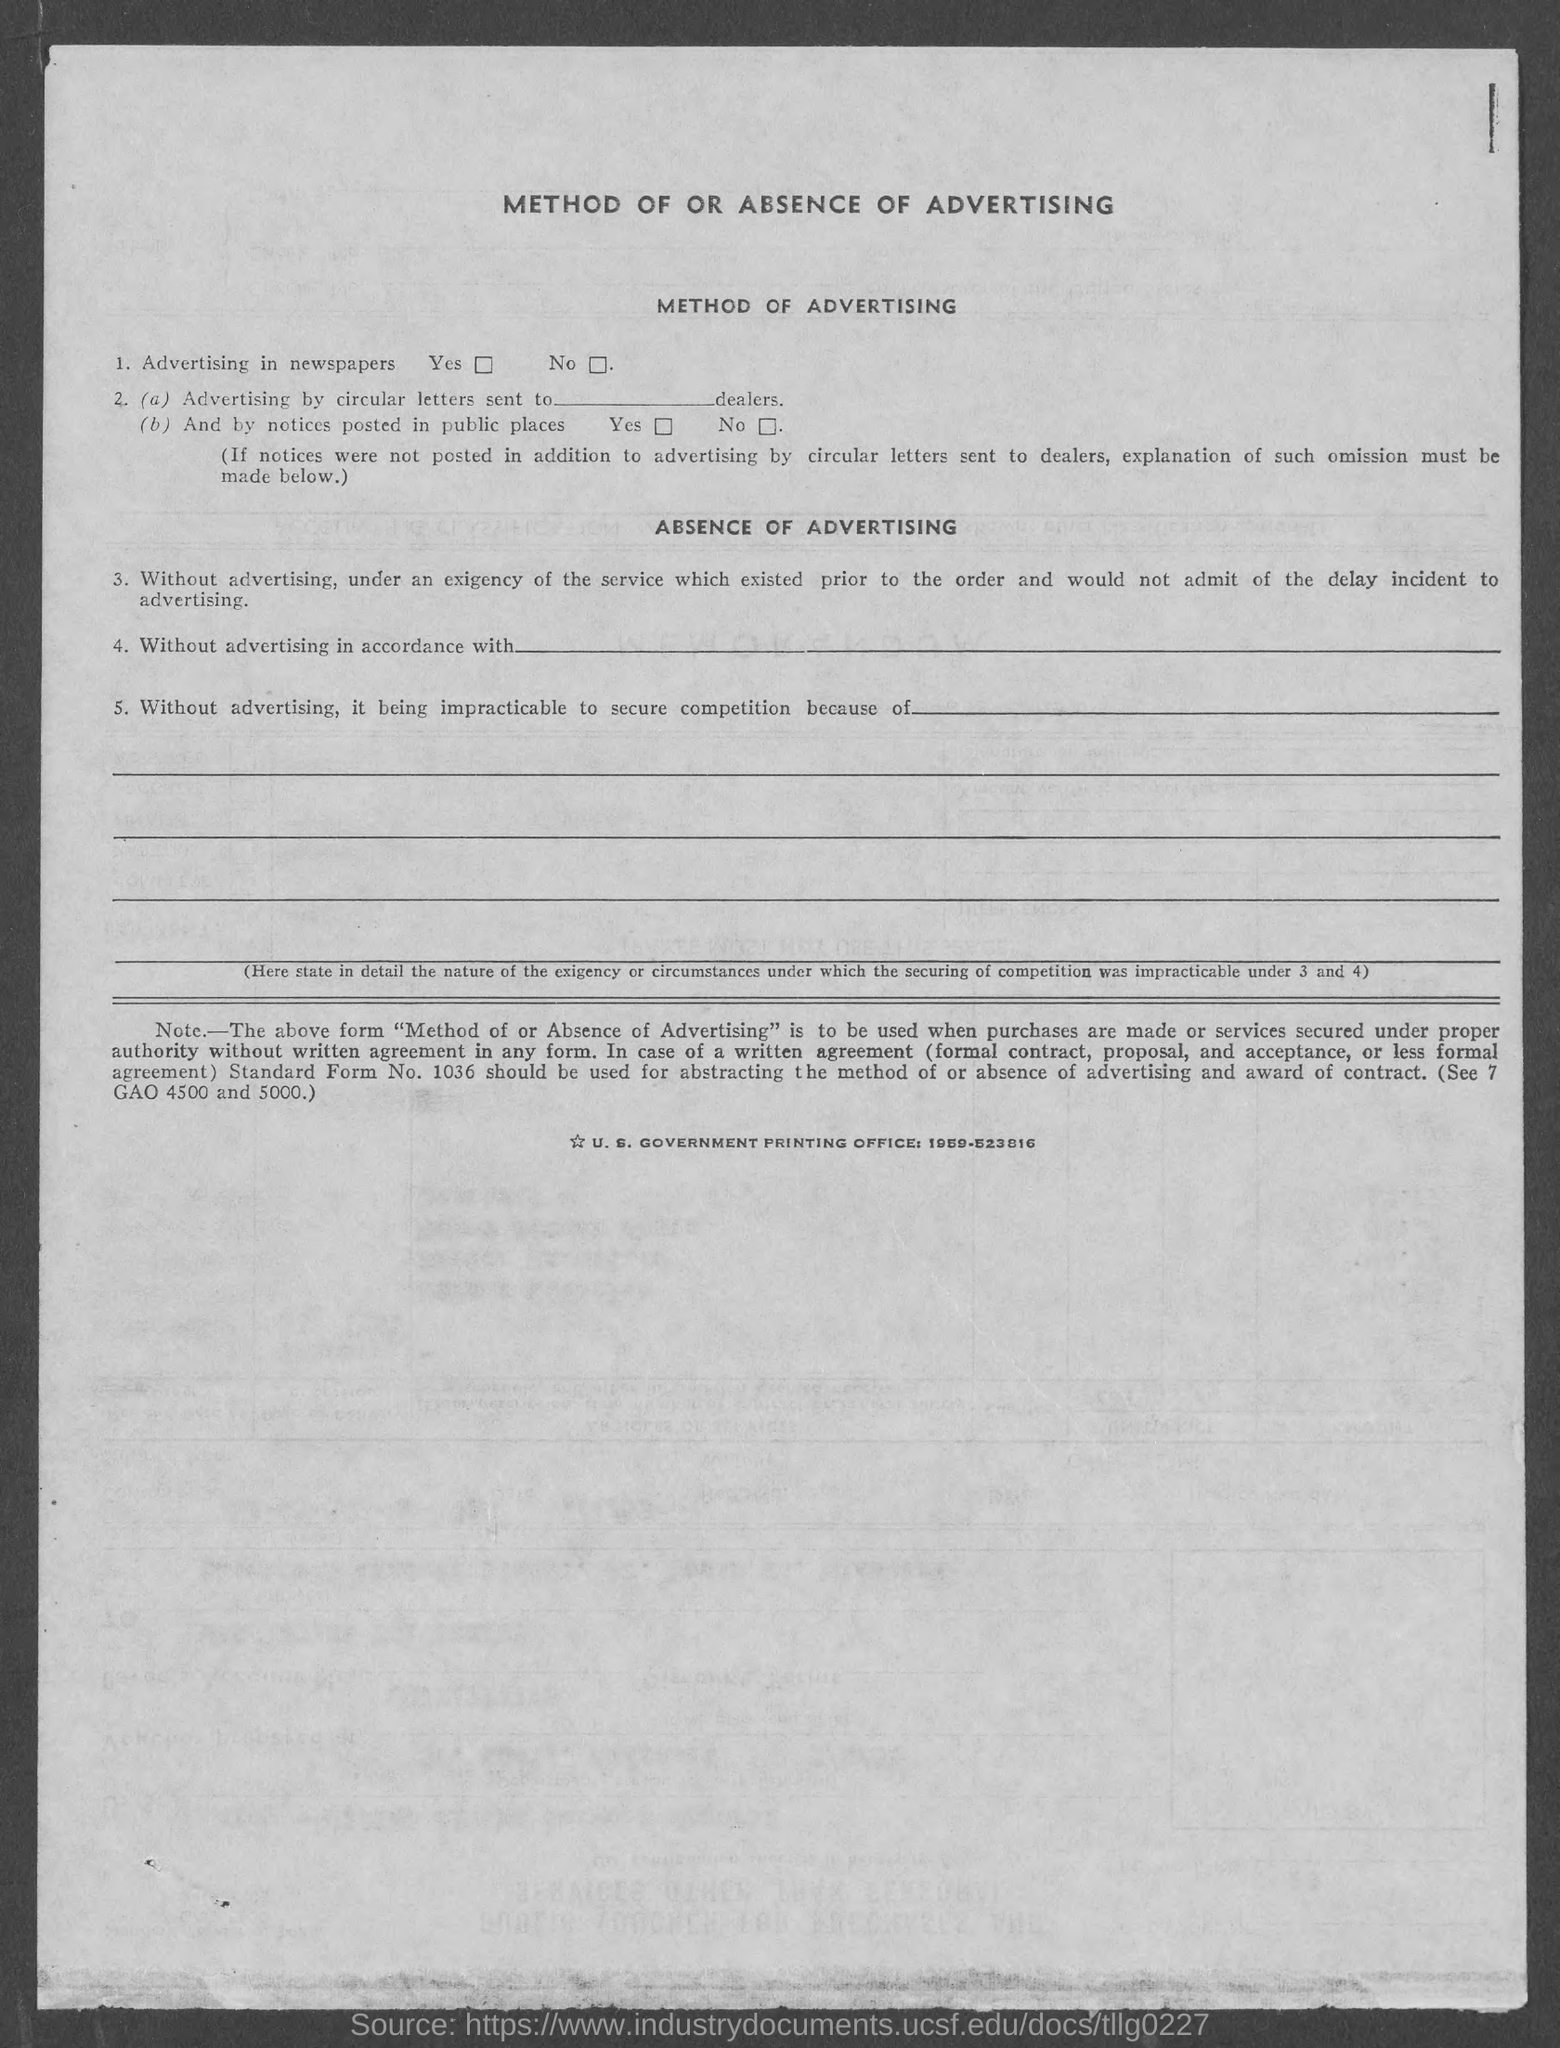Draw attention to some important aspects in this diagram. The first title in the document is 'METHOD OF OR ABSENCE OF ADVERTISING,' which raises questions about the effectiveness of advertising in achieving business goals. The second title in the document is "METHOD OF ADVERTISING.. The third title in the document is 'Absence of Advertising,' which highlights the absence of advertising in the sample document. 